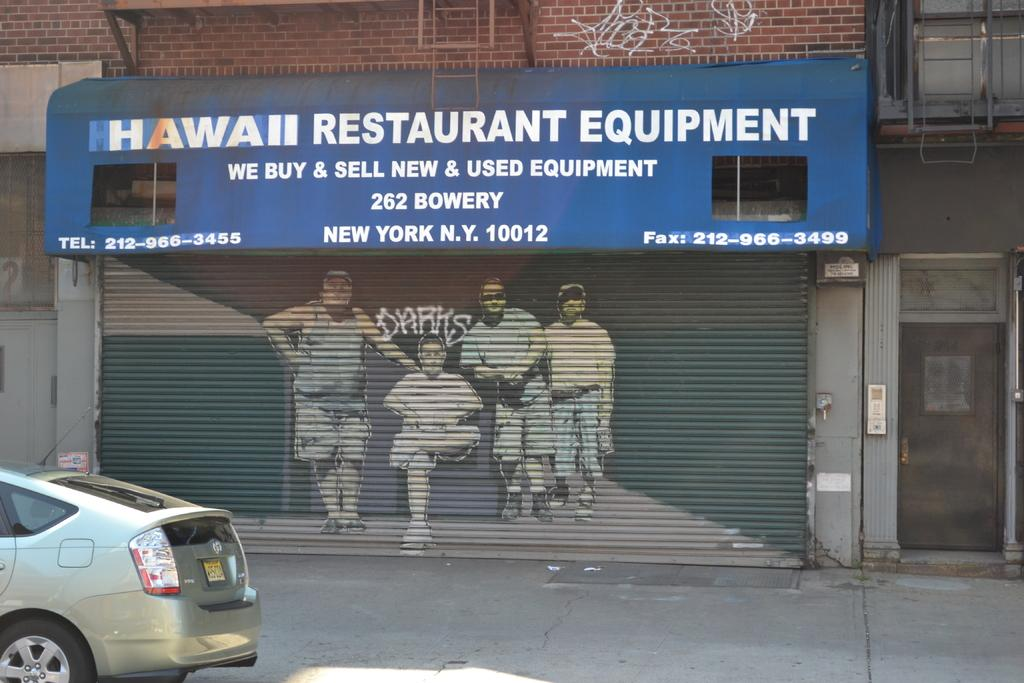What is the main subject of the image? The main subject of the image is a store shutter. What is depicted on the store shutter? The store shutter has a painting of men on it. What else can be seen in the image besides the store shutter? There is a car visible in the image. Where is the car located in the image? The car is on the road. How many horses can be seen on the floor in the image? There are no horses present in the image, and the floor is not visible in the image. 